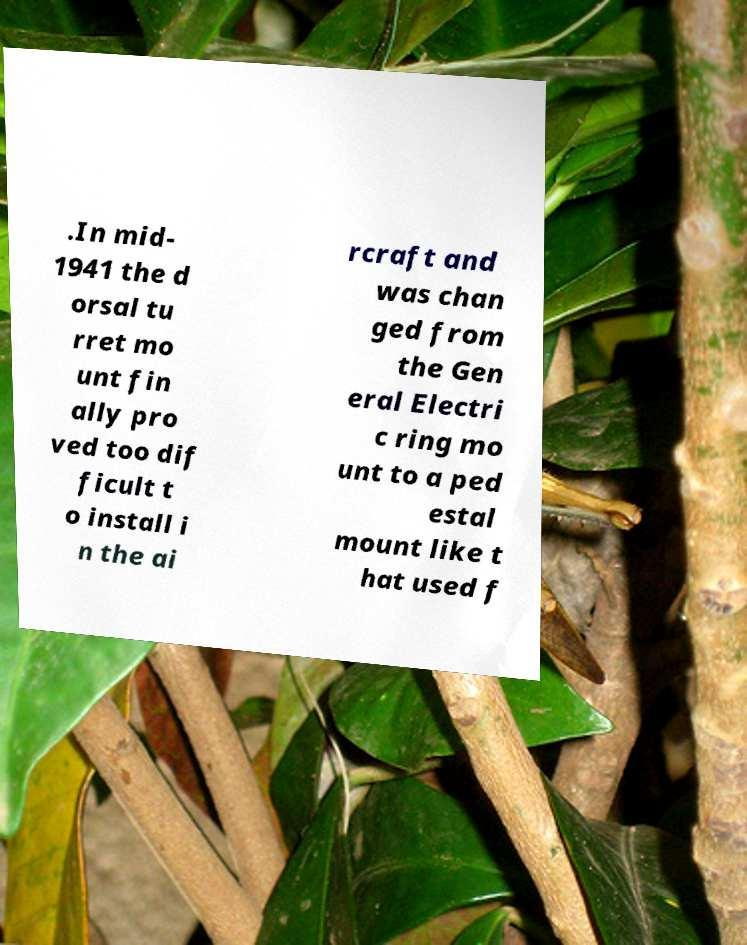Please identify and transcribe the text found in this image. .In mid- 1941 the d orsal tu rret mo unt fin ally pro ved too dif ficult t o install i n the ai rcraft and was chan ged from the Gen eral Electri c ring mo unt to a ped estal mount like t hat used f 